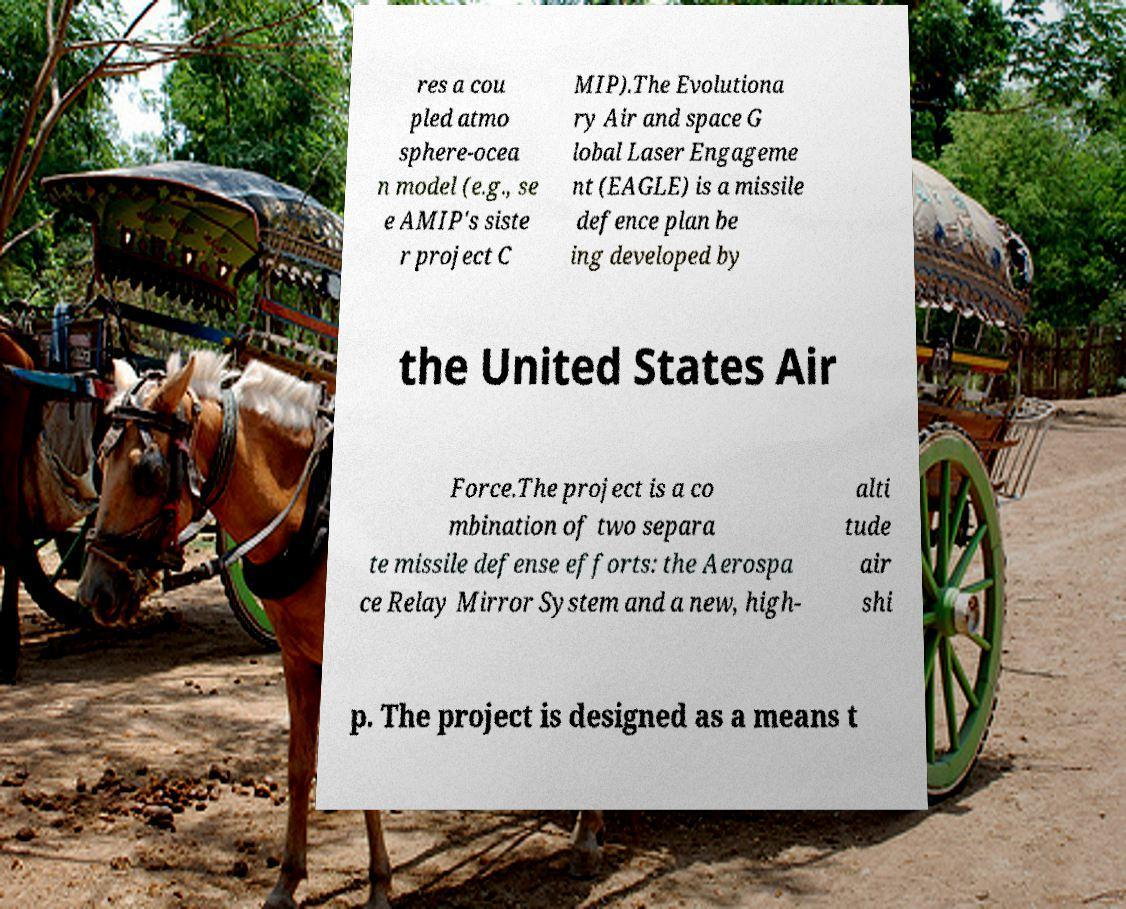I need the written content from this picture converted into text. Can you do that? res a cou pled atmo sphere-ocea n model (e.g., se e AMIP's siste r project C MIP).The Evolutiona ry Air and space G lobal Laser Engageme nt (EAGLE) is a missile defence plan be ing developed by the United States Air Force.The project is a co mbination of two separa te missile defense efforts: the Aerospa ce Relay Mirror System and a new, high- alti tude air shi p. The project is designed as a means t 